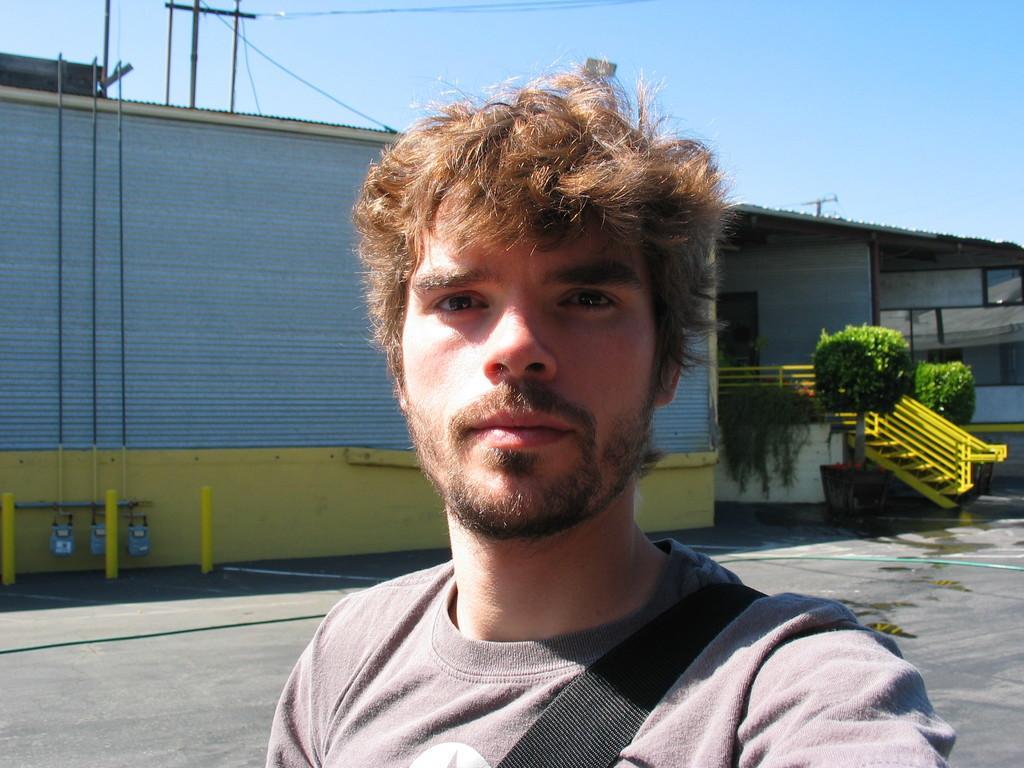In one or two sentences, can you explain what this image depicts? In this image we can see a person standing on the road and we can also see railing, planter, poles and sky. 